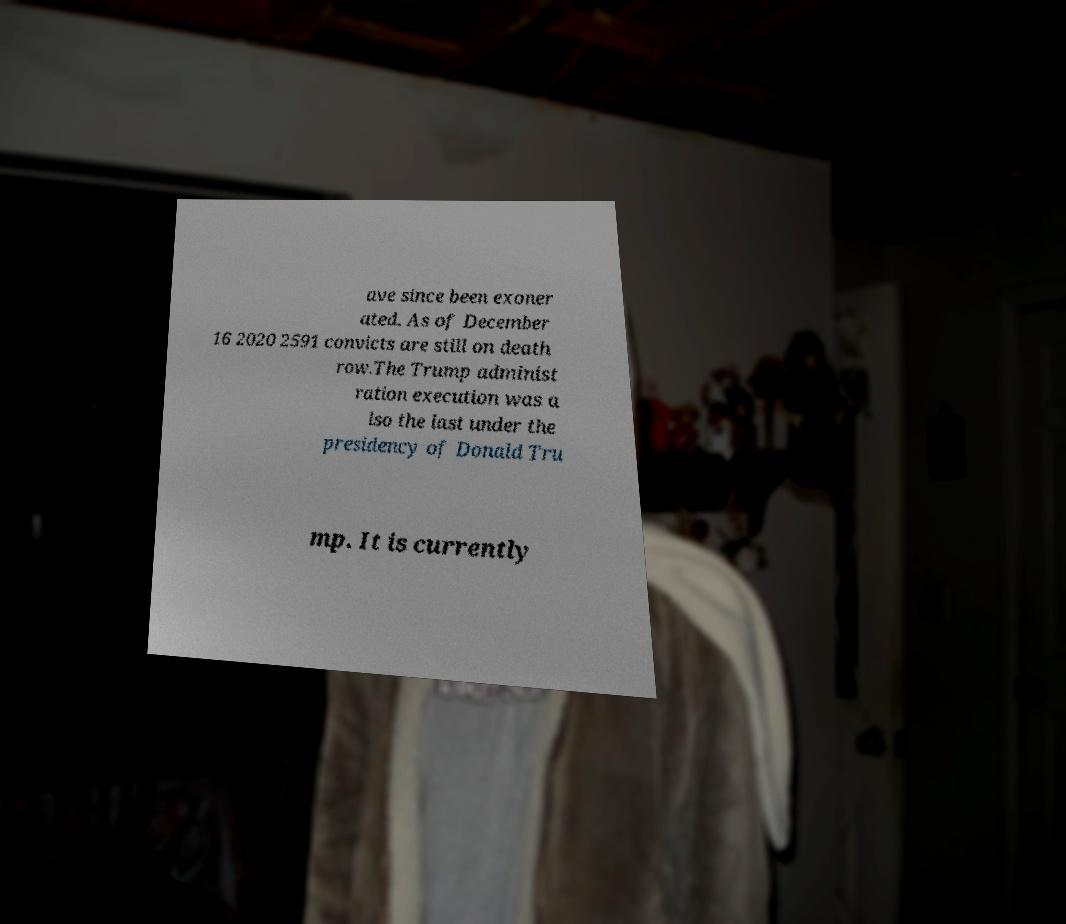Please identify and transcribe the text found in this image. ave since been exoner ated. As of December 16 2020 2591 convicts are still on death row.The Trump administ ration execution was a lso the last under the presidency of Donald Tru mp. It is currently 